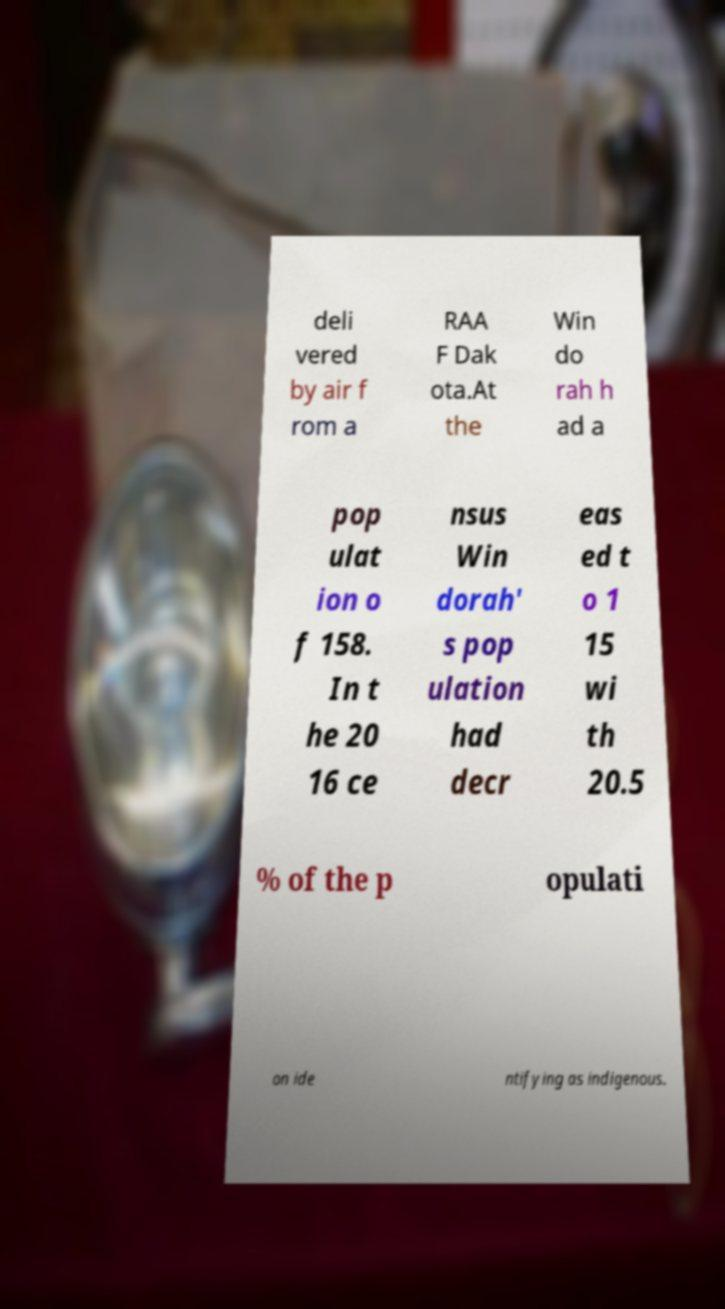I need the written content from this picture converted into text. Can you do that? deli vered by air f rom a RAA F Dak ota.At the Win do rah h ad a pop ulat ion o f 158. In t he 20 16 ce nsus Win dorah' s pop ulation had decr eas ed t o 1 15 wi th 20.5 % of the p opulati on ide ntifying as indigenous. 